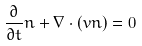Convert formula to latex. <formula><loc_0><loc_0><loc_500><loc_500>\frac { \partial } { \partial t } n + \nabla \cdot \left ( { v } n \right ) = 0</formula> 